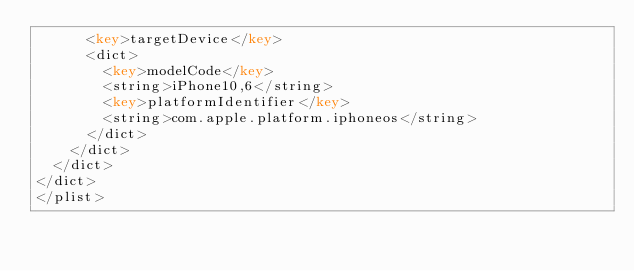Convert code to text. <code><loc_0><loc_0><loc_500><loc_500><_XML_>			<key>targetDevice</key>
			<dict>
				<key>modelCode</key>
				<string>iPhone10,6</string>
				<key>platformIdentifier</key>
				<string>com.apple.platform.iphoneos</string>
			</dict>
		</dict>
	</dict>
</dict>
</plist>
</code> 